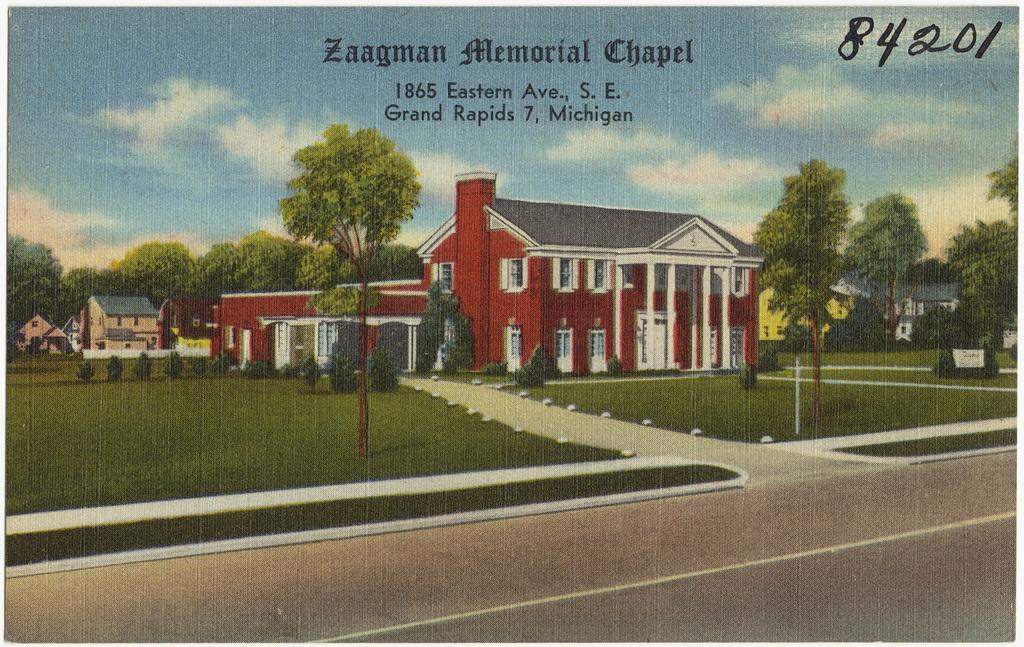What is the main feature of the image? There is a banner in the image. What is depicted on the banner? The banner contains a painting of houses. What elements are included in the painting on the banner? The painting on the banner includes plants, trees, grass, sky, and clouds. Is there any text on the banner? Yes, there is text written on the banner. What type of grain is being offered in the image? There is no grain present in the image. Is there a bag visible in the image? There is no bag visible in the image. 